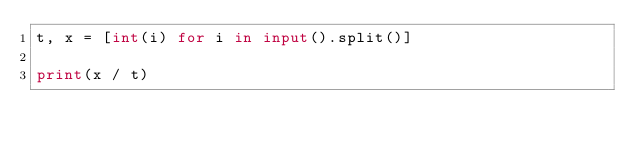<code> <loc_0><loc_0><loc_500><loc_500><_Python_>t, x = [int(i) for i in input().split()]

print(x / t)
</code> 